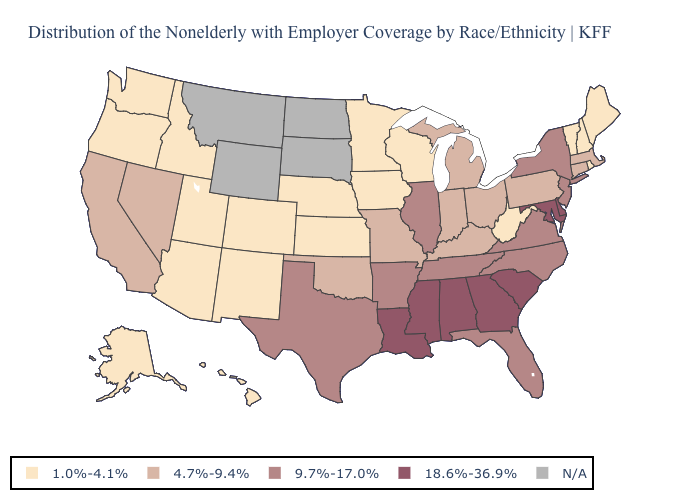Does the map have missing data?
Give a very brief answer. Yes. Which states have the lowest value in the USA?
Quick response, please. Alaska, Arizona, Colorado, Hawaii, Idaho, Iowa, Kansas, Maine, Minnesota, Nebraska, New Hampshire, New Mexico, Oregon, Rhode Island, Utah, Vermont, Washington, West Virginia, Wisconsin. What is the value of New York?
Short answer required. 9.7%-17.0%. What is the highest value in states that border New Mexico?
Keep it brief. 9.7%-17.0%. What is the value of Michigan?
Be succinct. 4.7%-9.4%. Does the map have missing data?
Short answer required. Yes. What is the value of Minnesota?
Be succinct. 1.0%-4.1%. Name the states that have a value in the range 4.7%-9.4%?
Answer briefly. California, Connecticut, Indiana, Kentucky, Massachusetts, Michigan, Missouri, Nevada, Ohio, Oklahoma, Pennsylvania. Does Delaware have the highest value in the USA?
Quick response, please. Yes. Which states have the lowest value in the USA?
Quick response, please. Alaska, Arizona, Colorado, Hawaii, Idaho, Iowa, Kansas, Maine, Minnesota, Nebraska, New Hampshire, New Mexico, Oregon, Rhode Island, Utah, Vermont, Washington, West Virginia, Wisconsin. What is the value of Colorado?
Give a very brief answer. 1.0%-4.1%. Name the states that have a value in the range 1.0%-4.1%?
Short answer required. Alaska, Arizona, Colorado, Hawaii, Idaho, Iowa, Kansas, Maine, Minnesota, Nebraska, New Hampshire, New Mexico, Oregon, Rhode Island, Utah, Vermont, Washington, West Virginia, Wisconsin. What is the value of California?
Concise answer only. 4.7%-9.4%. Name the states that have a value in the range 1.0%-4.1%?
Keep it brief. Alaska, Arizona, Colorado, Hawaii, Idaho, Iowa, Kansas, Maine, Minnesota, Nebraska, New Hampshire, New Mexico, Oregon, Rhode Island, Utah, Vermont, Washington, West Virginia, Wisconsin. 